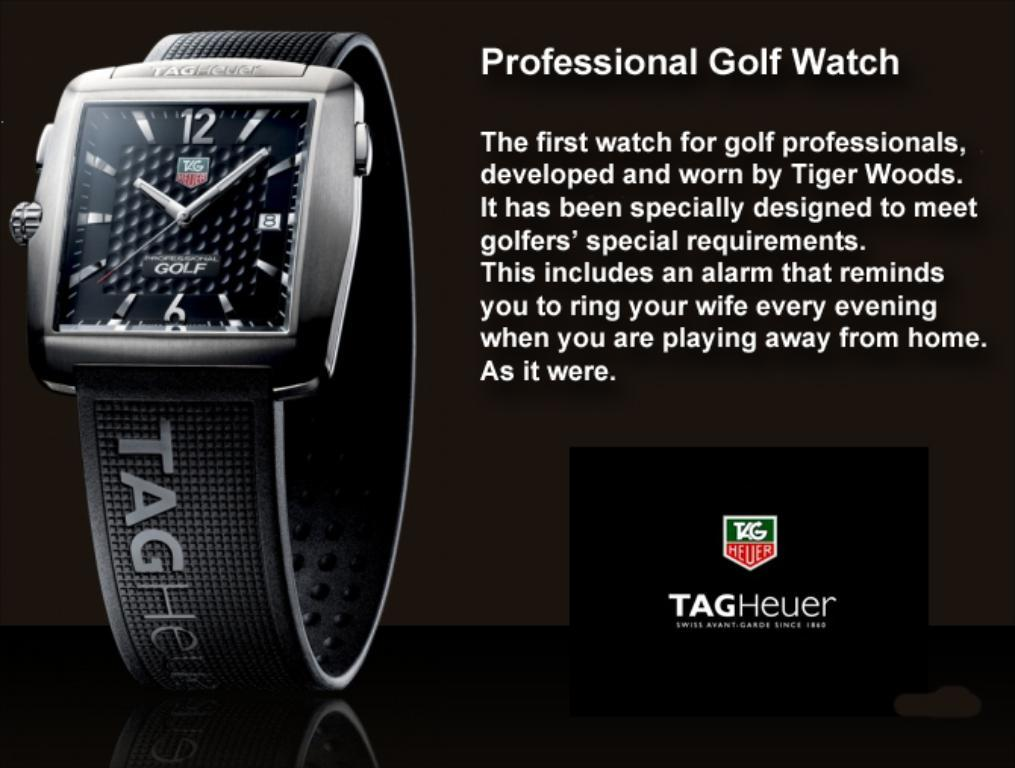<image>
Create a compact narrative representing the image presented. A professional golf watch developed by Tiger Woods 